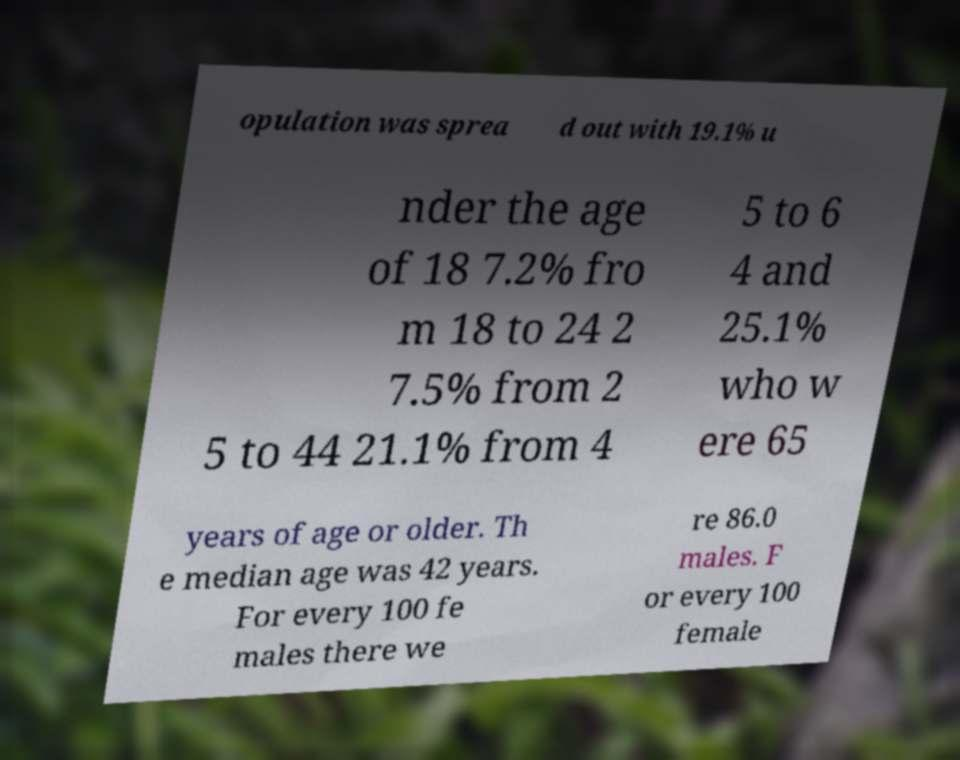For documentation purposes, I need the text within this image transcribed. Could you provide that? opulation was sprea d out with 19.1% u nder the age of 18 7.2% fro m 18 to 24 2 7.5% from 2 5 to 44 21.1% from 4 5 to 6 4 and 25.1% who w ere 65 years of age or older. Th e median age was 42 years. For every 100 fe males there we re 86.0 males. F or every 100 female 